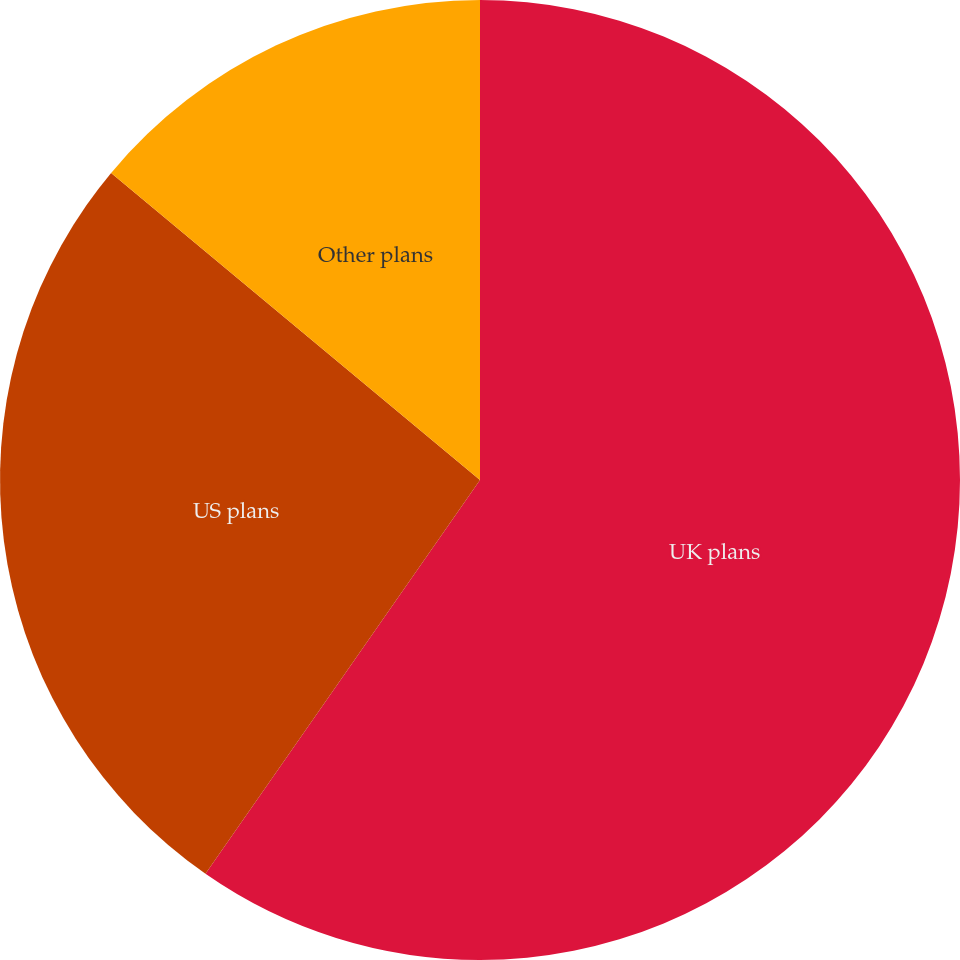<chart> <loc_0><loc_0><loc_500><loc_500><pie_chart><fcel>UK plans<fcel>US plans<fcel>Other plans<nl><fcel>59.69%<fcel>26.36%<fcel>13.95%<nl></chart> 